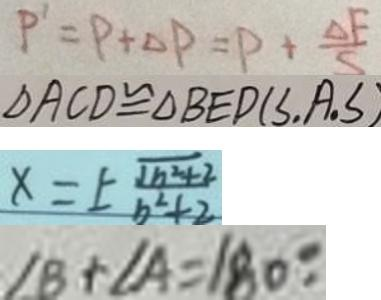<formula> <loc_0><loc_0><loc_500><loc_500>P ^ { \prime } = P + \Delta P = P + \frac { \Delta F } { S } 
 \Delta A C D \cong \Delta B E D ( S , A . S ) 
 x = \pm \frac { \sqrt { b ^ { 2 } + 2 } } { b ^ { 2 } + 2 } 
 \angle B + \angle A = 1 8 0 ^ { \circ } .</formula> 